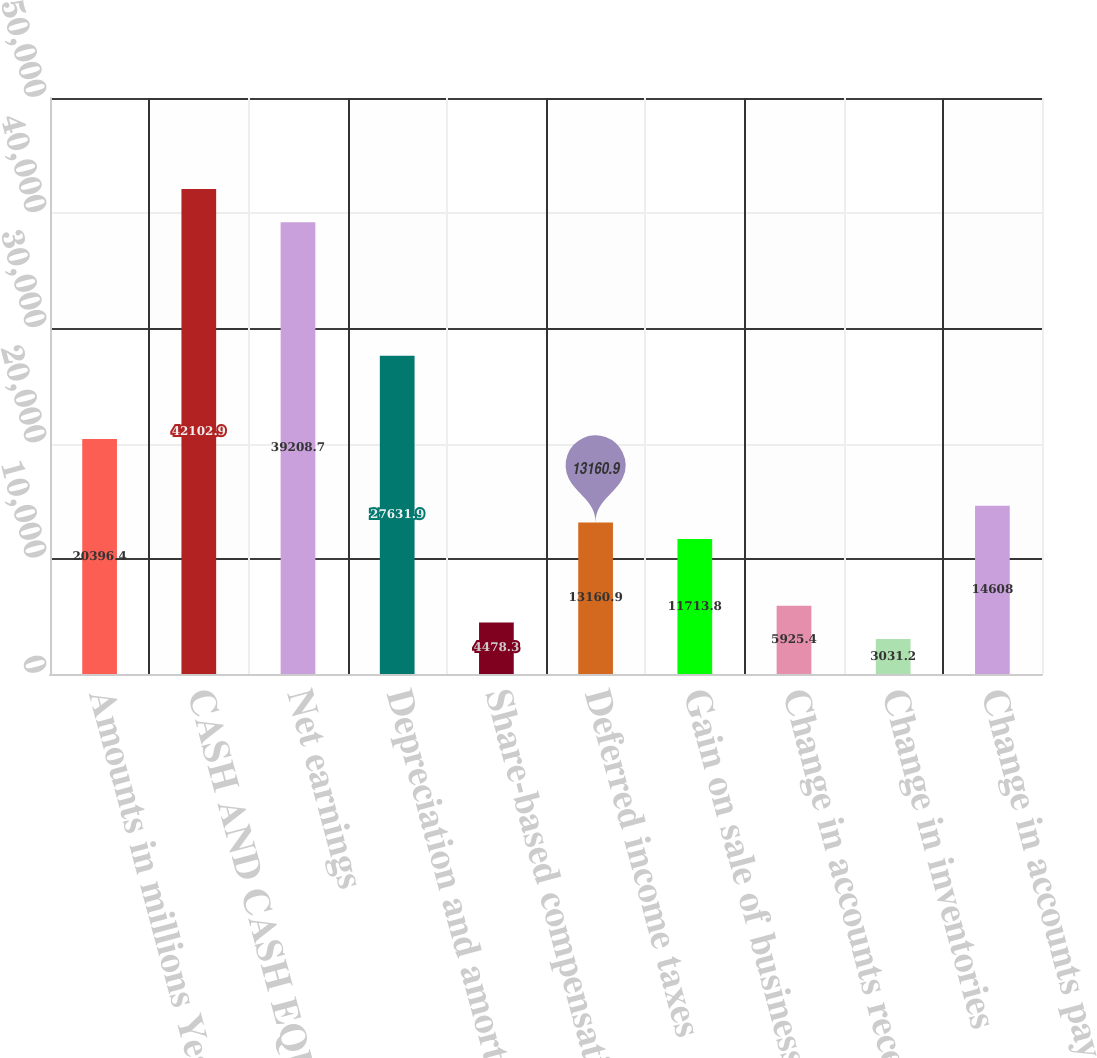Convert chart. <chart><loc_0><loc_0><loc_500><loc_500><bar_chart><fcel>Amounts in millions Years<fcel>CASH AND CASH EQUIVALENTS<fcel>Net earnings<fcel>Depreciation and amortization<fcel>Share-based compensation<fcel>Deferred income taxes<fcel>Gain on sale of businesses<fcel>Change in accounts receivable<fcel>Change in inventories<fcel>Change in accounts payable<nl><fcel>20396.4<fcel>42102.9<fcel>39208.7<fcel>27631.9<fcel>4478.3<fcel>13160.9<fcel>11713.8<fcel>5925.4<fcel>3031.2<fcel>14608<nl></chart> 